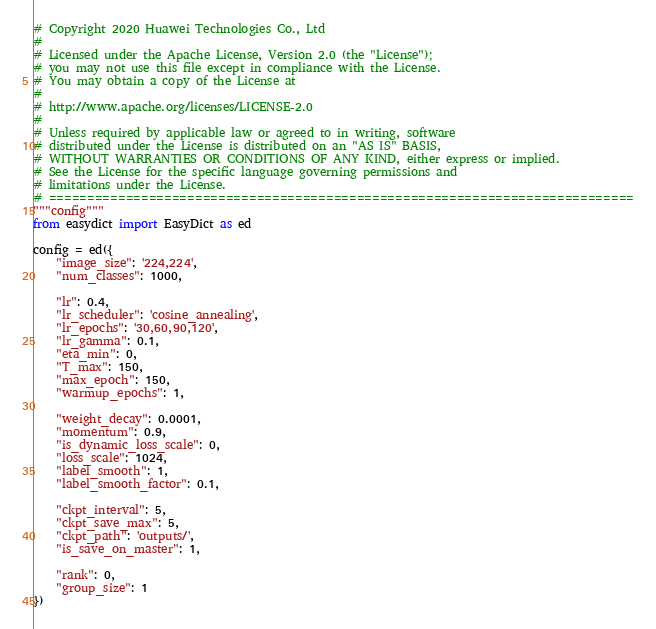Convert code to text. <code><loc_0><loc_0><loc_500><loc_500><_Python_># Copyright 2020 Huawei Technologies Co., Ltd
#
# Licensed under the Apache License, Version 2.0 (the "License");
# you may not use this file except in compliance with the License.
# You may obtain a copy of the License at
#
# http://www.apache.org/licenses/LICENSE-2.0
#
# Unless required by applicable law or agreed to in writing, software
# distributed under the License is distributed on an "AS IS" BASIS,
# WITHOUT WARRANTIES OR CONDITIONS OF ANY KIND, either express or implied.
# See the License for the specific language governing permissions and
# limitations under the License.
# ============================================================================
"""config"""
from easydict import EasyDict as ed

config = ed({
    "image_size": '224,224',
    "num_classes": 1000,

    "lr": 0.4,
    "lr_scheduler": 'cosine_annealing',
    "lr_epochs": '30,60,90,120',
    "lr_gamma": 0.1,
    "eta_min": 0,
    "T_max": 150,
    "max_epoch": 150,
    "warmup_epochs": 1,

    "weight_decay": 0.0001,
    "momentum": 0.9,
    "is_dynamic_loss_scale": 0,
    "loss_scale": 1024,
    "label_smooth": 1,
    "label_smooth_factor": 0.1,

    "ckpt_interval": 5,
    "ckpt_save_max": 5,
    "ckpt_path": 'outputs/',
    "is_save_on_master": 1,

    "rank": 0,
    "group_size": 1
})
</code> 